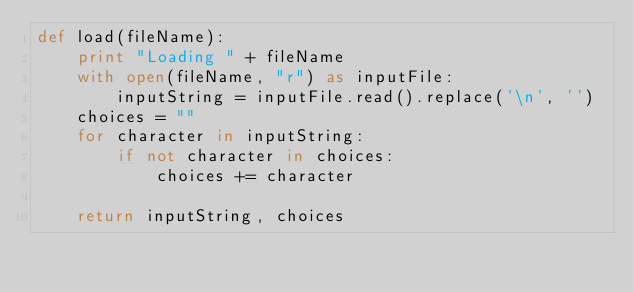<code> <loc_0><loc_0><loc_500><loc_500><_Python_>def load(fileName):
    print "Loading " + fileName
    with open(fileName, "r") as inputFile:
        inputString = inputFile.read().replace('\n', '')
    choices = ""
    for character in inputString:
        if not character in choices:
            choices += character

    return inputString, choices</code> 